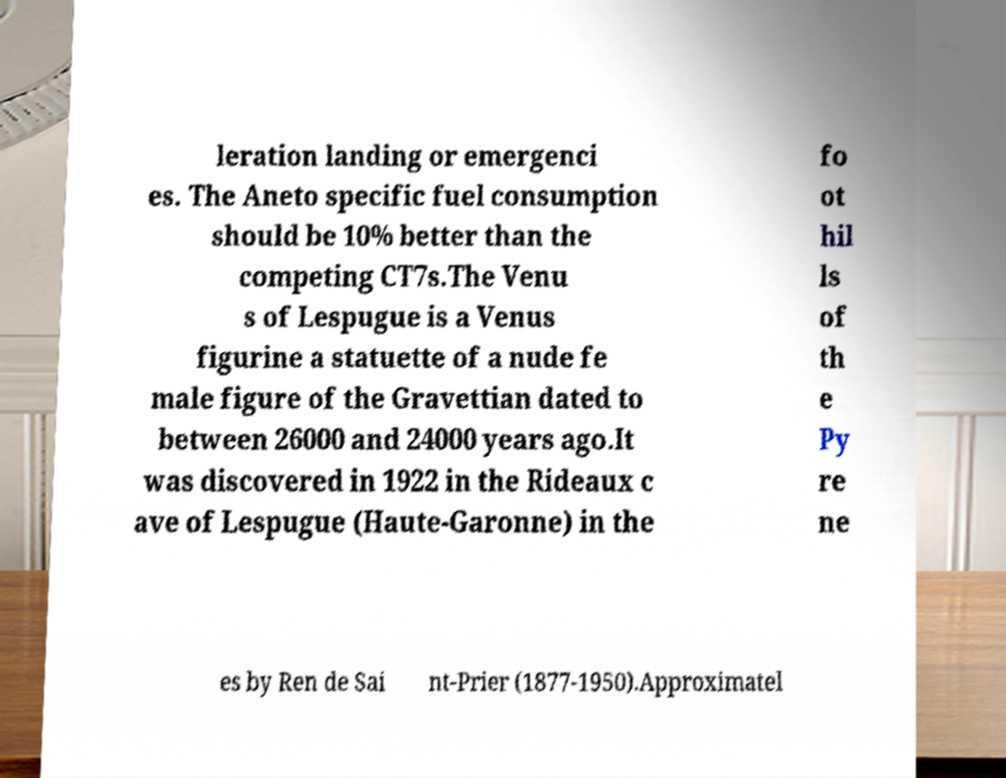I need the written content from this picture converted into text. Can you do that? leration landing or emergenci es. The Aneto specific fuel consumption should be 10% better than the competing CT7s.The Venu s of Lespugue is a Venus figurine a statuette of a nude fe male figure of the Gravettian dated to between 26000 and 24000 years ago.It was discovered in 1922 in the Rideaux c ave of Lespugue (Haute-Garonne) in the fo ot hil ls of th e Py re ne es by Ren de Sai nt-Prier (1877-1950).Approximatel 